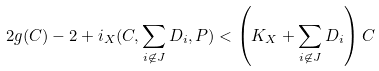<formula> <loc_0><loc_0><loc_500><loc_500>2 g ( C ) - 2 + i _ { X } ( C , \sum _ { i \not \in J } D _ { i } , P ) < \left ( K _ { X } + \sum _ { i \not \in J } D _ { i } \right ) C</formula> 